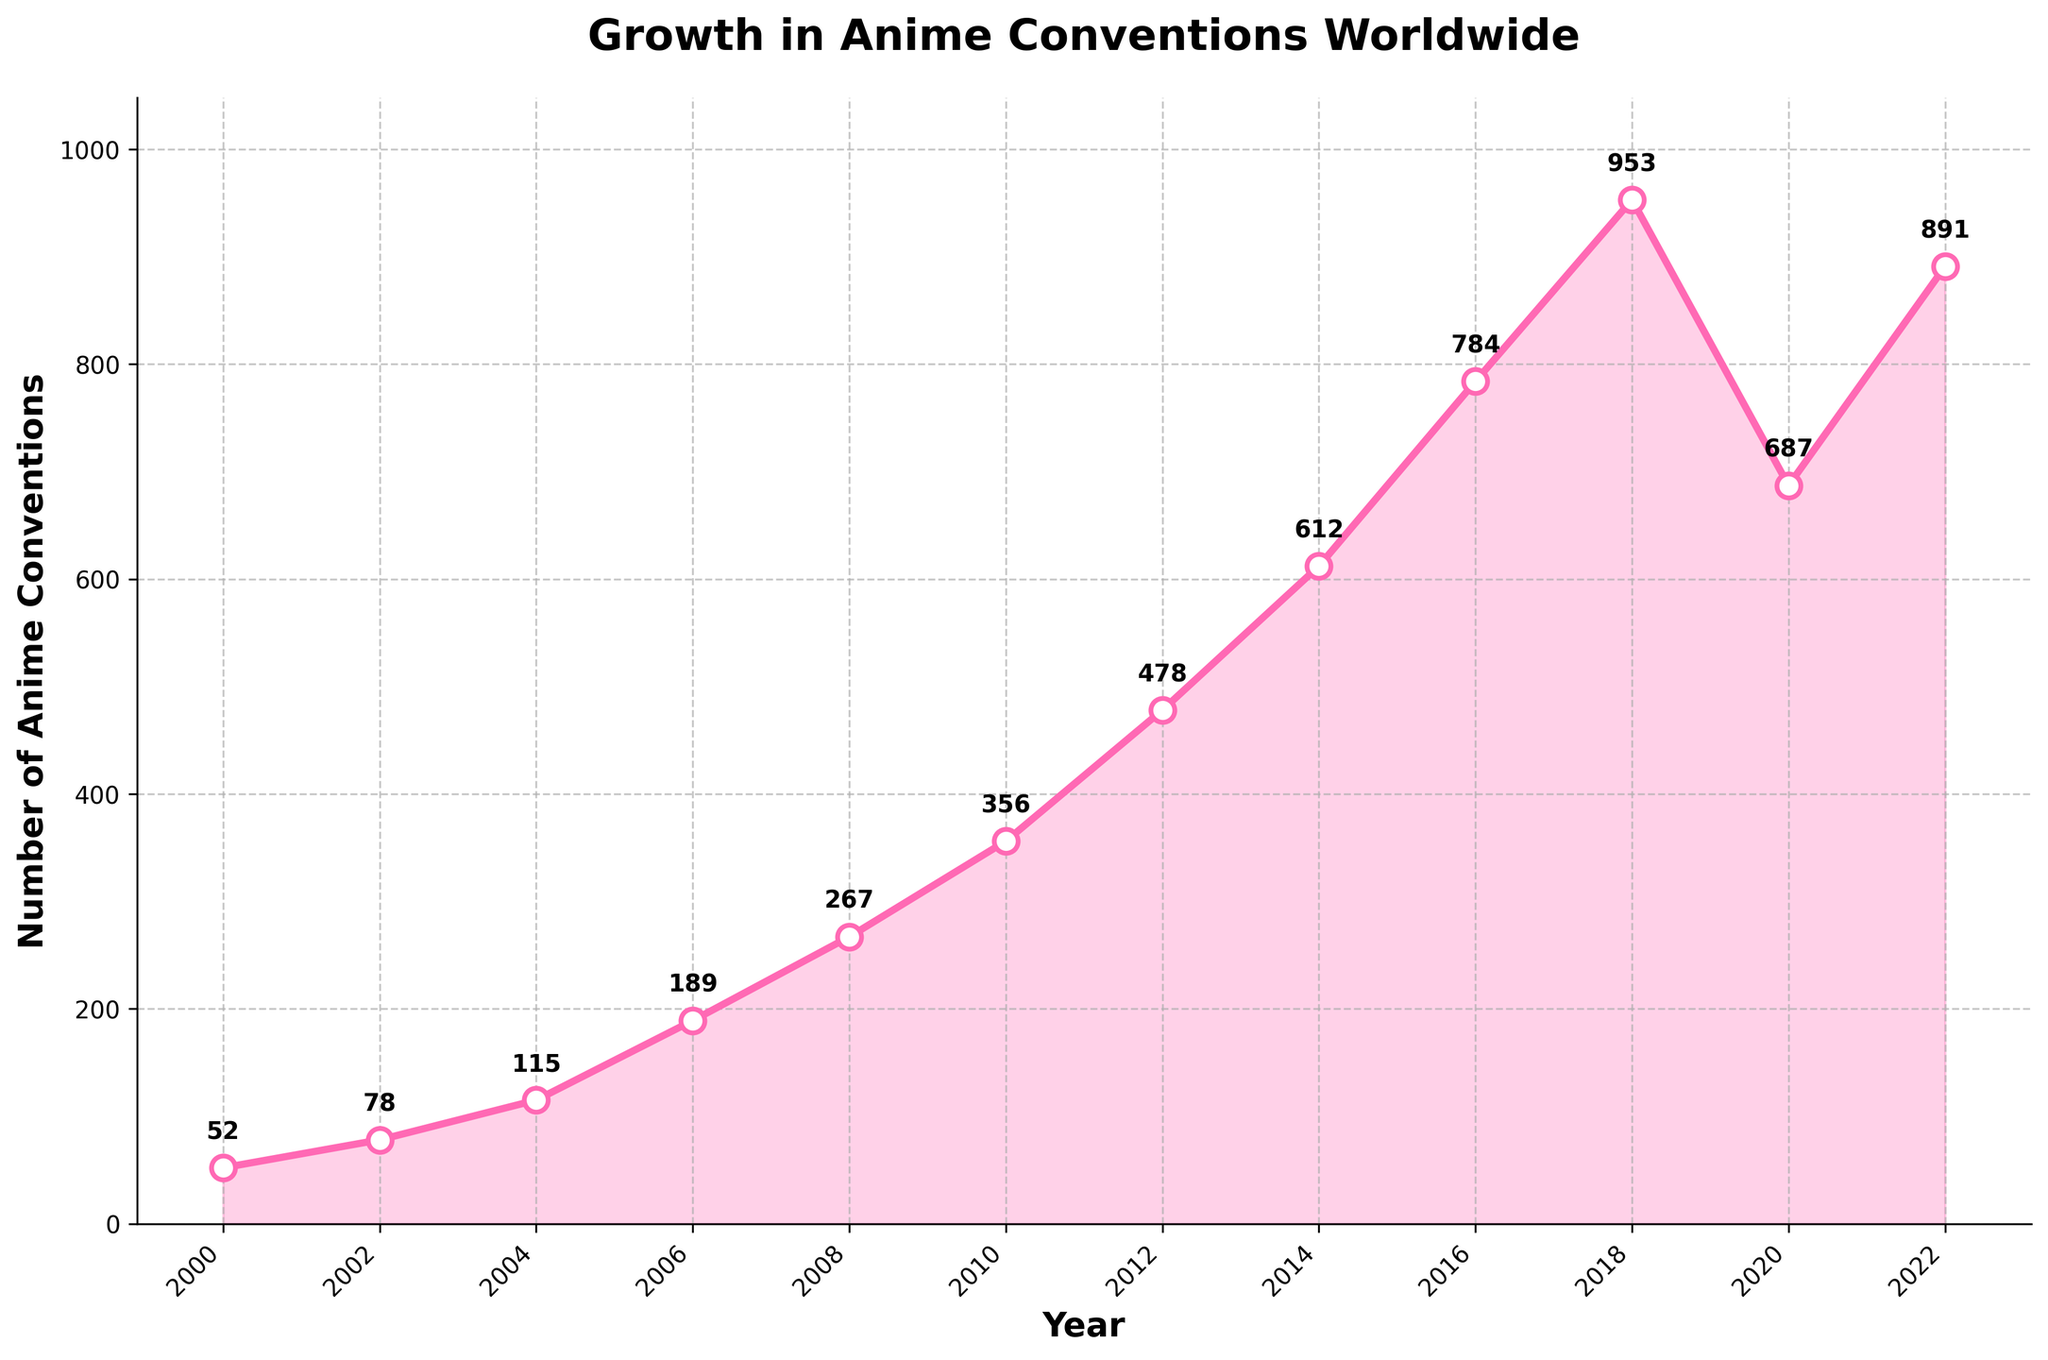How many more anime conventions were there in 2018 compared to 2002? To find the difference between the number of conventions in 2018 and 2002, subtract the number of conventions in 2002 from the number in 2018: 953 - 78 = 875
Answer: 875 In which year did the number of anime conventions worldwide first exceed 500? By examining the plot, we observe that the number of conventions rises above 500 between 2012 and 2014. In 2014, the number of conventions reached 612, which is the first time it exceeded 500.
Answer: 2014 What was the average number of anime conventions worldwide between 2000 and 2022? To find the average, sum all the values from 2000 to 2022, then divide by the total number of years: (52 + 78 + 115 + 189 + 267 + 356 + 478 + 612 + 784 + 953 + 687 + 891) / 12 = (5462 / 12) ≈ 455.17
Answer: 455.17 Which year saw the highest number of anime conventions? From the plot, it is clear that the highest number of conventions occurred in 2018 when the count was 953.
Answer: 2018 How did the number of anime conventions change between 2018 and 2020? By comparing the values in 2018 and 2020, we see that the number dropped from 953 to 687. By calculating, 953 - 687 = 266. Therefore, there was a decrease of 266 conventions.
Answer: Decreased by 266 What period saw the highest growth in the number of conventions? Observing the plot, the steepest increase appears between 2010 and 2012 when the number rose from 356 to 478. Calculating the difference, 478 - 356 = 122.
Answer: 2010 to 2012 Which year had fewer conventions than both 2012 and 2014 but more than 2010? Evaluate the years in comparison to 2012 (478), 2014 (612), and 2010 (356). The year 2012 roles out 2008 and earlier, and 2016 and later are ruled out by 2014. Hence, the year fitting this condition is 2012.
Answer: 2012 